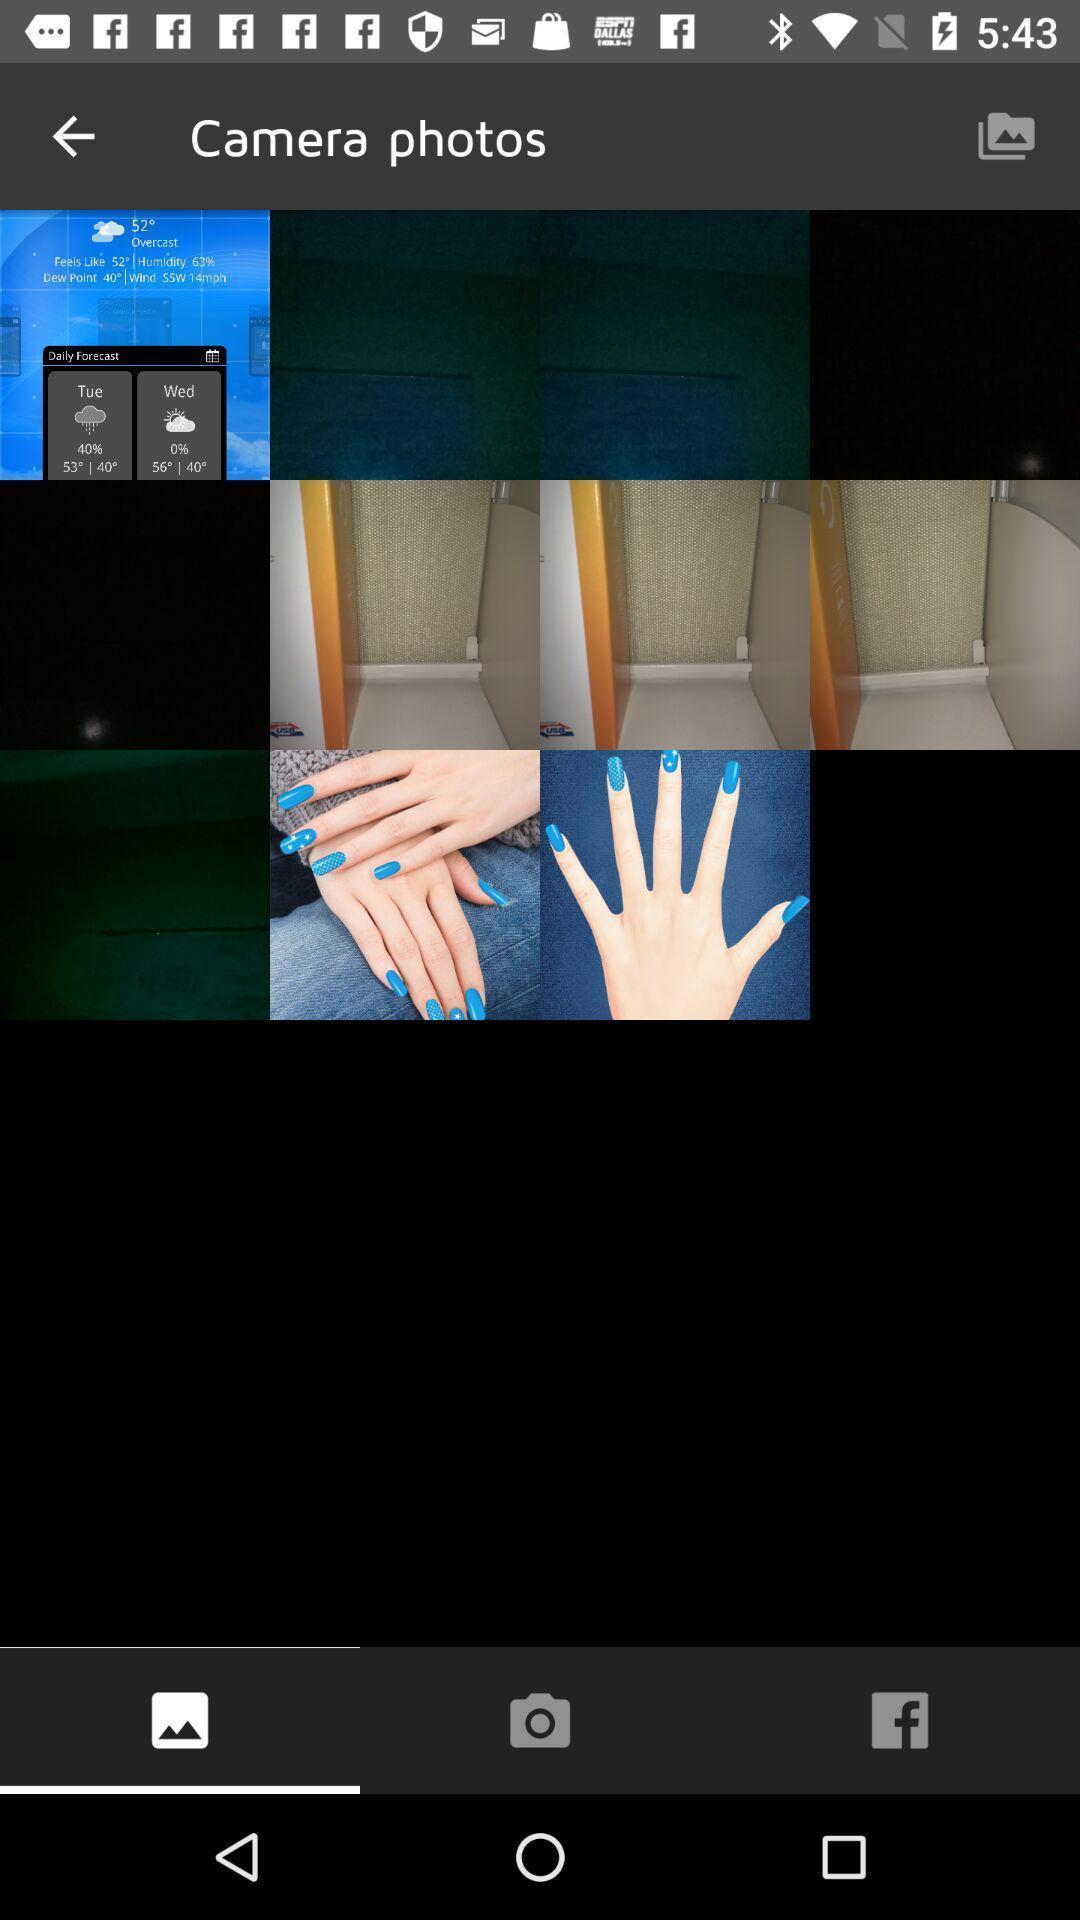Tell me what you see in this picture. Various kinds of pictures in the gallery application. 